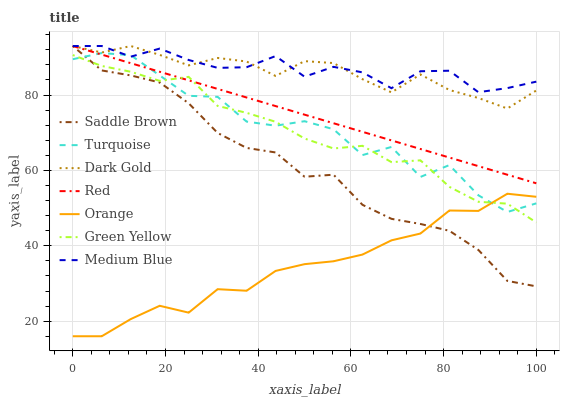Does Orange have the minimum area under the curve?
Answer yes or no. Yes. Does Medium Blue have the maximum area under the curve?
Answer yes or no. Yes. Does Dark Gold have the minimum area under the curve?
Answer yes or no. No. Does Dark Gold have the maximum area under the curve?
Answer yes or no. No. Is Red the smoothest?
Answer yes or no. Yes. Is Turquoise the roughest?
Answer yes or no. Yes. Is Dark Gold the smoothest?
Answer yes or no. No. Is Dark Gold the roughest?
Answer yes or no. No. Does Dark Gold have the lowest value?
Answer yes or no. No. Does Red have the highest value?
Answer yes or no. Yes. Does Orange have the highest value?
Answer yes or no. No. Is Turquoise less than Dark Gold?
Answer yes or no. Yes. Is Dark Gold greater than Orange?
Answer yes or no. Yes. Does Medium Blue intersect Dark Gold?
Answer yes or no. Yes. Is Medium Blue less than Dark Gold?
Answer yes or no. No. Is Medium Blue greater than Dark Gold?
Answer yes or no. No. Does Turquoise intersect Dark Gold?
Answer yes or no. No. 